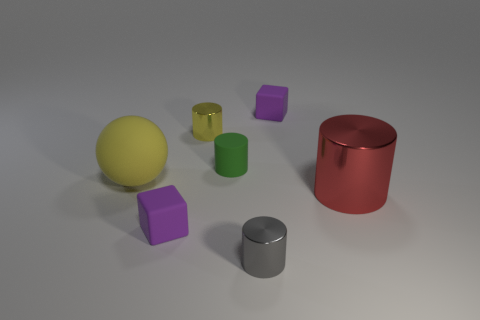What number of other objects are the same material as the tiny green cylinder?
Give a very brief answer. 3. The matte ball is what size?
Offer a terse response. Large. How many other objects are the same color as the sphere?
Your answer should be very brief. 1. There is a tiny thing that is on the left side of the rubber cylinder and in front of the red object; what is its color?
Provide a short and direct response. Purple. How many gray metallic cylinders are there?
Keep it short and to the point. 1. Is the material of the large red cylinder the same as the yellow cylinder?
Your answer should be compact. Yes. What is the shape of the large object left of the small matte cube that is behind the purple matte object that is left of the green matte thing?
Make the answer very short. Sphere. Does the tiny block in front of the large cylinder have the same material as the tiny purple block that is behind the small green cylinder?
Provide a succinct answer. Yes. What is the small green cylinder made of?
Offer a very short reply. Rubber. What number of other big red objects are the same shape as the red shiny thing?
Provide a succinct answer. 0. 